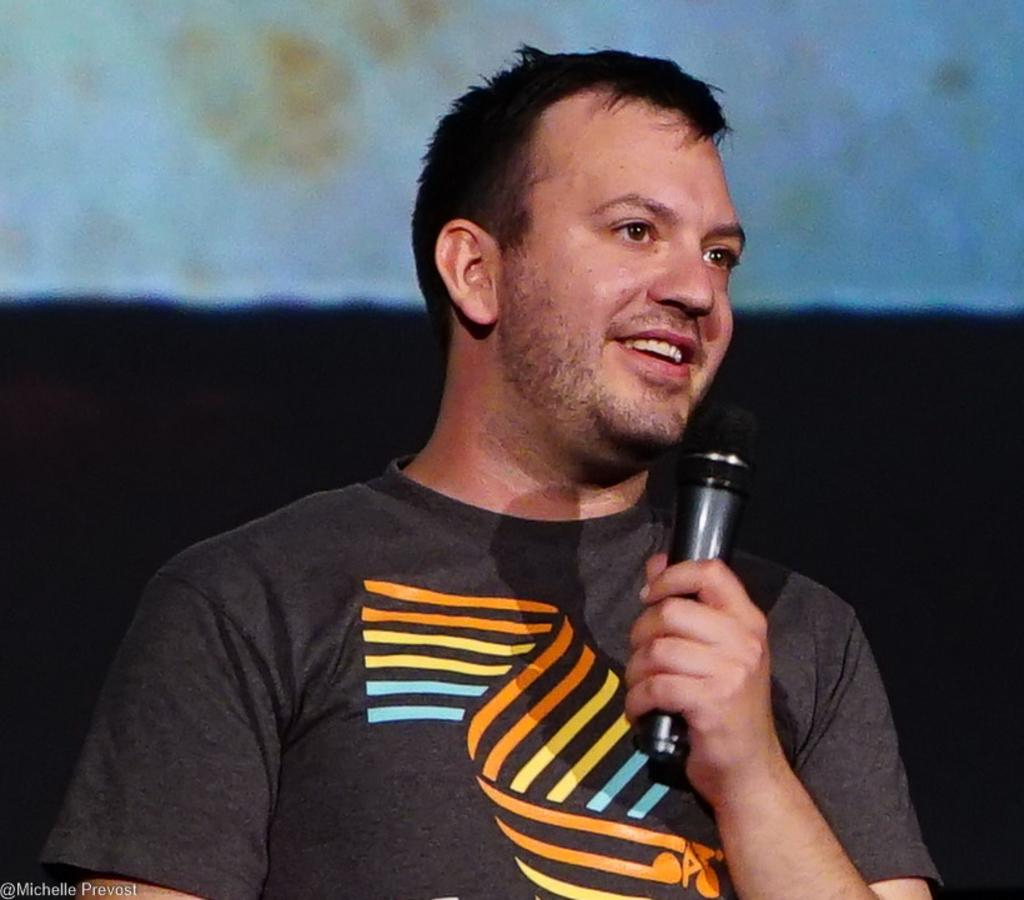Who is present in the image? There is a person in the image. What is the person wearing? The person is wearing a black t-shirt. What is the person holding in the image? The person is holding a microphone. What type of stove is visible in the image? There is no stove present in the image. How does the person's death relate to the image? The image does not depict any death or imply any connection to death. 